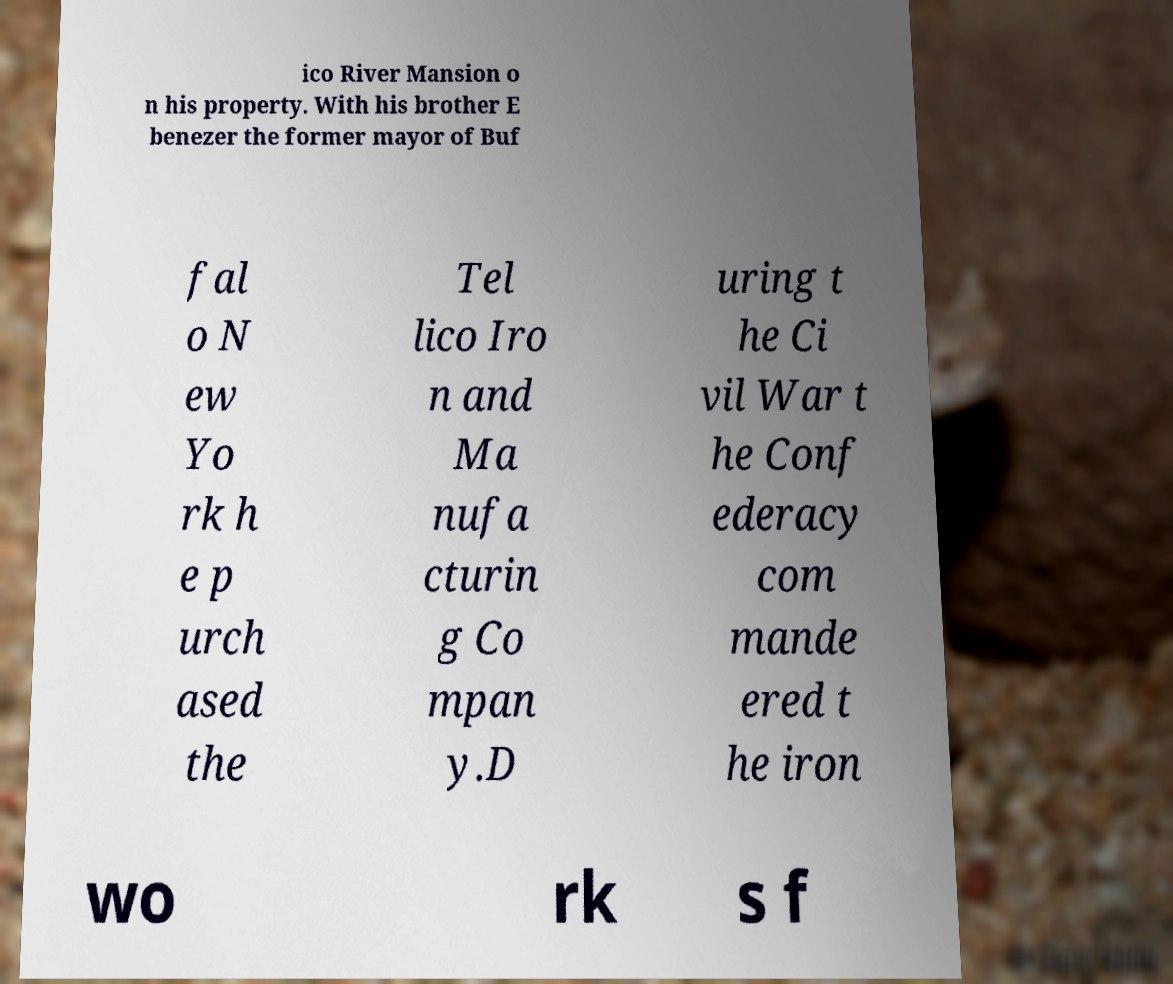For documentation purposes, I need the text within this image transcribed. Could you provide that? ico River Mansion o n his property. With his brother E benezer the former mayor of Buf fal o N ew Yo rk h e p urch ased the Tel lico Iro n and Ma nufa cturin g Co mpan y.D uring t he Ci vil War t he Conf ederacy com mande ered t he iron wo rk s f 